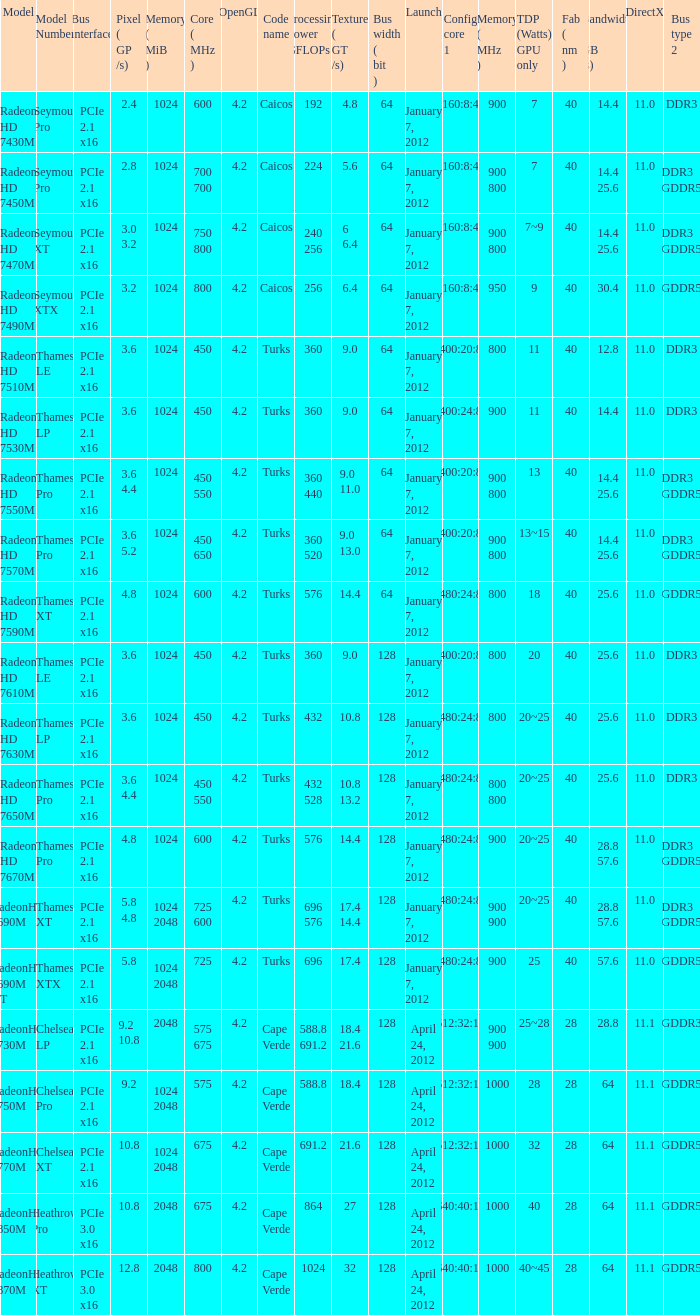What was the model's DirectX if it has a Core of 700 700 mhz? 11.0. 